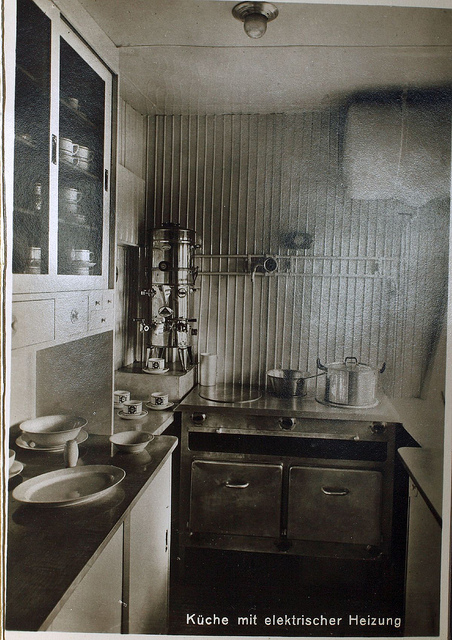Please extract the text content from this image. mit elektrischer Heizung 